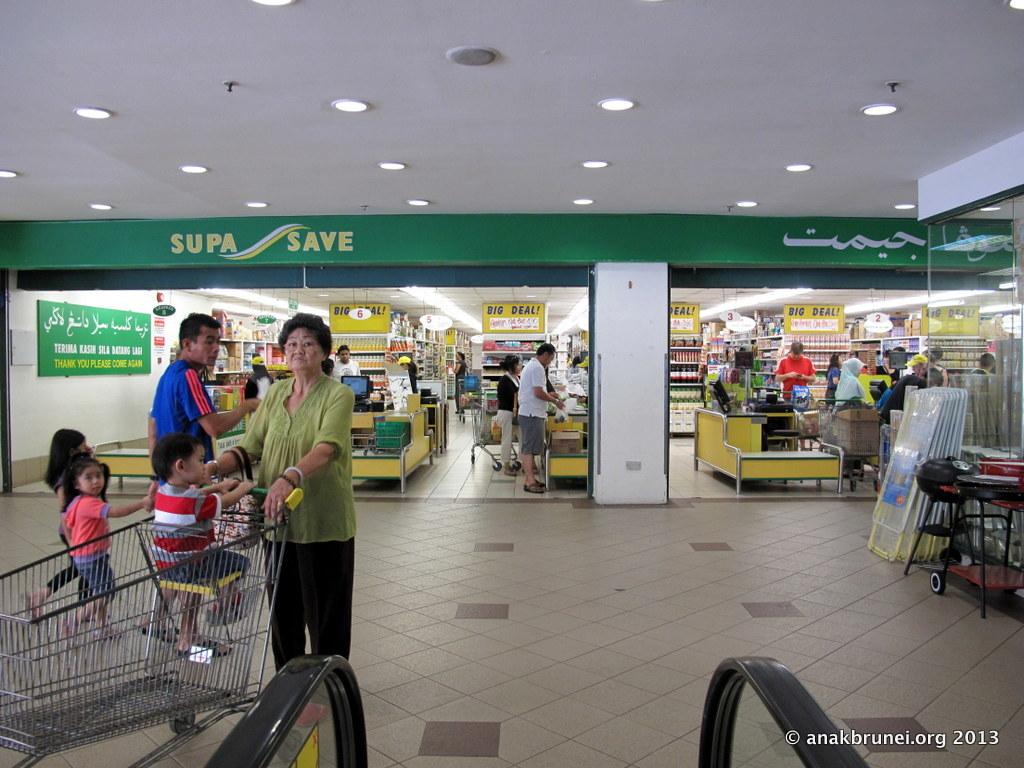How many people can be seen in the image? There are people in the image. What is hanging in the image? There is a banner in the image. What is the background of the image made of? There is a wall in the image. What is providing illumination in the image? There are lights in the image. What type of vehicle is present in the image? There is a cart in the image. What type of objects are present for sitting or resting in the image? There are furnitures in the image. Can you see a maid holding a stick in the image? There is no maid or stick present in the image. What type of food is being prepared in a stew in the image? There is no stew or food preparation visible in the image. 